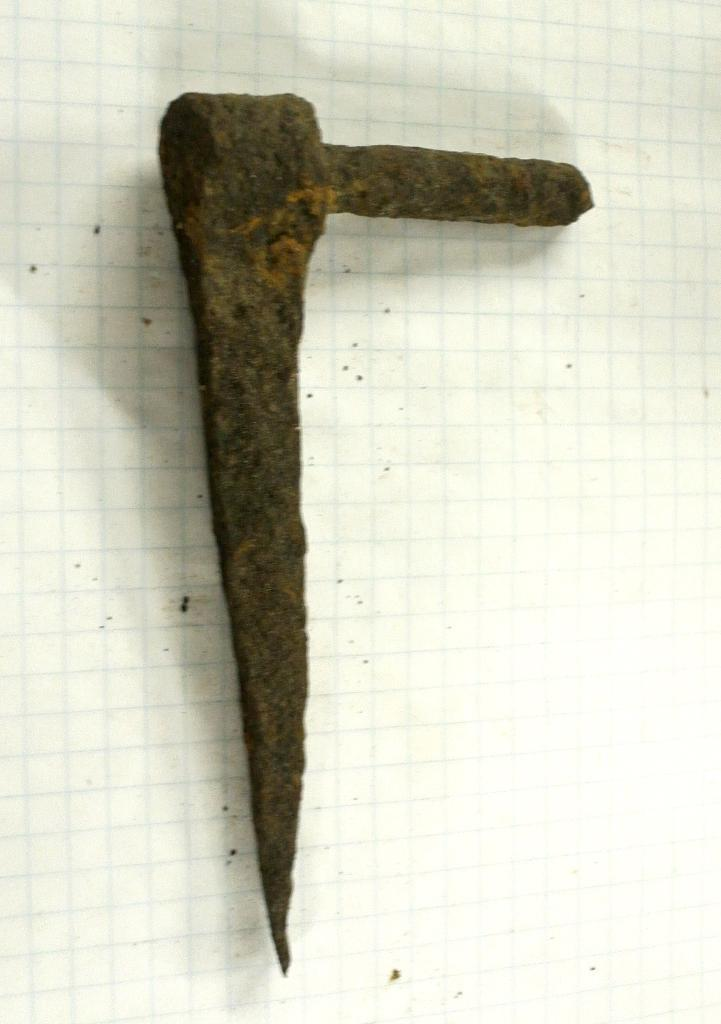What object can be seen in the image? There is a tool in the image. Where is the tool located? The tool is placed on a surface. What role does the father play in the tool's functionality in the image? There is no mention of a father or any person in the image, so it is not possible to determine their role in the tool's functionality. 